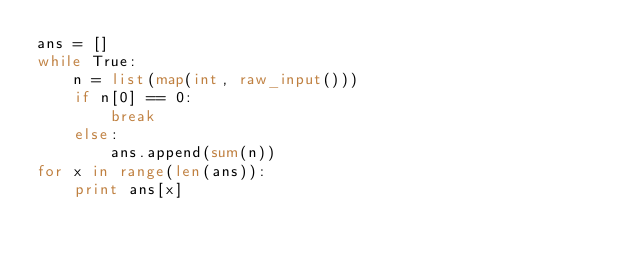<code> <loc_0><loc_0><loc_500><loc_500><_Python_>ans = []
while True:
    n = list(map(int, raw_input()))
    if n[0] == 0:
        break
    else:
        ans.append(sum(n))
for x in range(len(ans)):
    print ans[x]</code> 